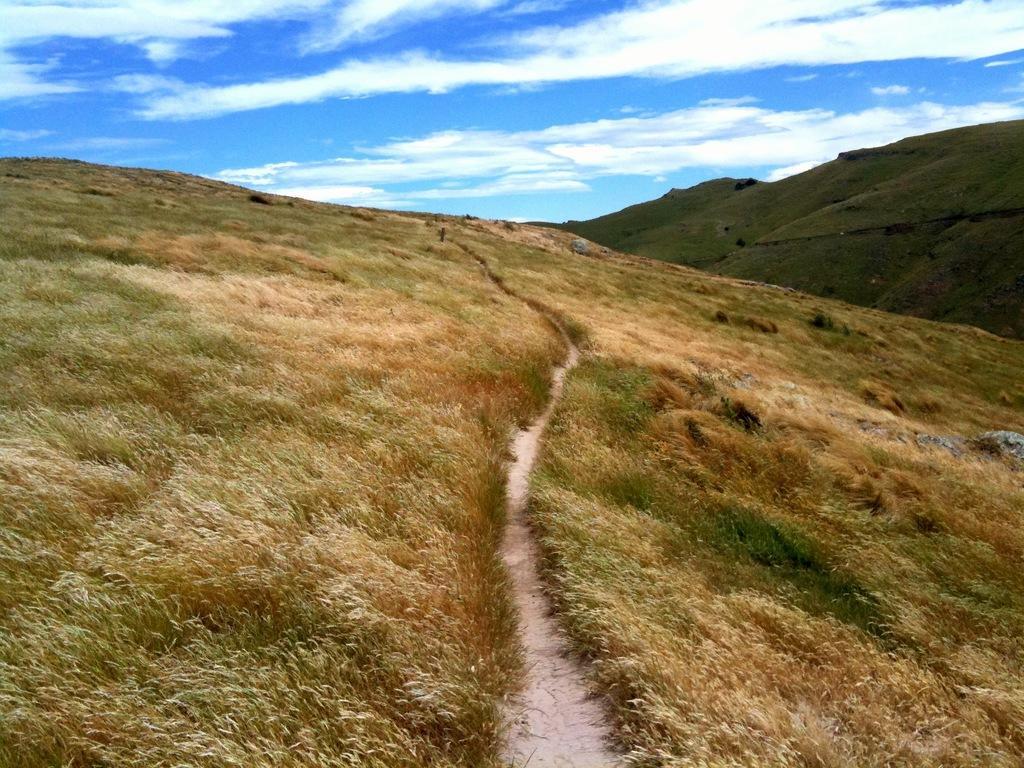In one or two sentences, can you explain what this image depicts? In this image there is grass. There are sand and stones. On the right side there are mountains. There are clouds in the sky. 